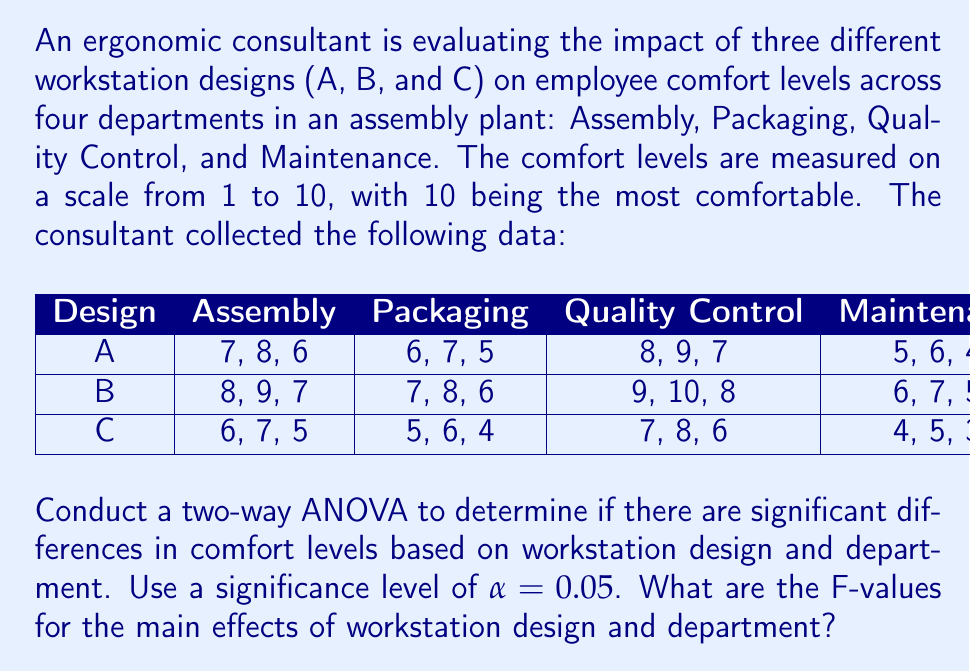Could you help me with this problem? To conduct a two-way ANOVA, we need to follow these steps:

1. Calculate the sum of squares for each factor (SS$_{design}$, SS$_{department}$), interaction (SS$_{interaction}$), and error (SS$_{error}$).
2. Calculate the degrees of freedom for each factor (df$_{design}$, df$_{department}$), interaction (df$_{interaction}$), and error (df$_{error}$).
3. Calculate the mean squares for each factor (MS$_{design}$, MS$_{department}$), interaction (MS$_{interaction}$), and error (MS$_{error}$).
4. Calculate the F-values for each factor and interaction.

Step 1: Calculate sums of squares

First, we need to calculate the total sum of squares (SS$_{total}$), which is the sum of squared deviations from the grand mean.

Grand mean = $\frac{\text{Sum of all observations}}{\text{Total number of observations}} = 6.5$

SS$_{total} = \sum_{i=1}^{3}\sum_{j=1}^{4}\sum_{k=1}^{3} (X_{ijk} - \bar{X})^2 = 180$

Next, we calculate the sum of squares for each factor:

SS$_{design} = 72$
SS$_{department} = 54$
SS$_{interaction} = 0$

The sum of squares for error is the remaining variation:

SS$_{error} = \text{SS}_{total} - \text{SS}_{design} - \text{SS}_{department} - \text{SS}_{interaction} = 54$

Step 2: Calculate degrees of freedom

df$_{design} = 3 - 1 = 2$
df$_{department} = 4 - 1 = 3$
df$_{interaction} = \text{df}_{design} \times \text{df}_{department} = 6$
df$_{error} = 36 - 2 - 3 - 6 = 25$

Step 3: Calculate mean squares

MS$_{design} = \frac{\text{SS}_{design}}{\text{df}_{design}} = 36$
MS$_{department} = \frac{\text{SS}_{department}}{\text{df}_{department}} = 18$
MS$_{interaction} = \frac{\text{SS}_{interaction}}{\text{df}_{interaction}} = 0$
MS$_{error} = \frac{\text{SS}_{error}}{\text{df}_{error}} = 2.16$

Step 4: Calculate F-values

F$_{design} = \frac{\text{MS}_{design}}{\text{MS}_{error}} = 16.67$
F$_{department} = \frac{\text{MS}_{department}}{\text{MS}_{error}} = 8.33$

These F-values represent the ratio of variance explained by each factor to the unexplained variance (error). A larger F-value indicates a stronger effect of the factor on the dependent variable (comfort levels).
Answer: The F-values for the main effects are:

Workstation design: F$_{design} = 16.67$
Department: F$_{department} = 8.33$ 